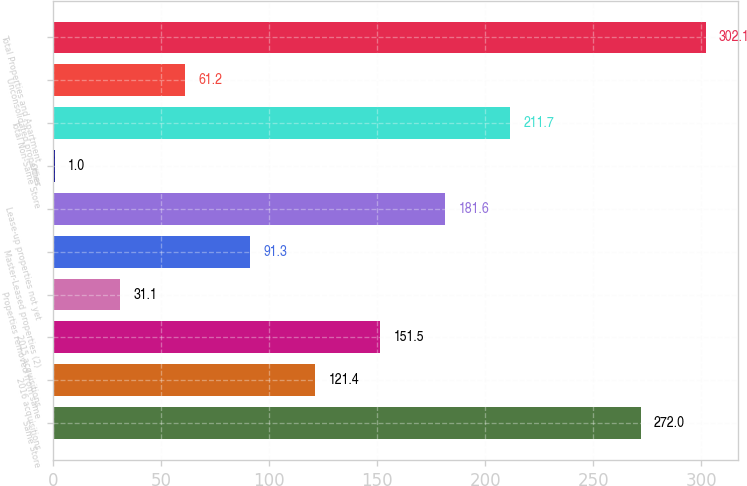Convert chart. <chart><loc_0><loc_0><loc_500><loc_500><bar_chart><fcel>Same Store<fcel>2016 acquisitions<fcel>2015 acquisitions<fcel>Properties removed from same<fcel>Master-Leased properties (2)<fcel>Lease-up properties not yet<fcel>Other<fcel>Total Non-Same Store<fcel>Unconsolidated properties<fcel>Total Properties and Apartment<nl><fcel>272<fcel>121.4<fcel>151.5<fcel>31.1<fcel>91.3<fcel>181.6<fcel>1<fcel>211.7<fcel>61.2<fcel>302.1<nl></chart> 